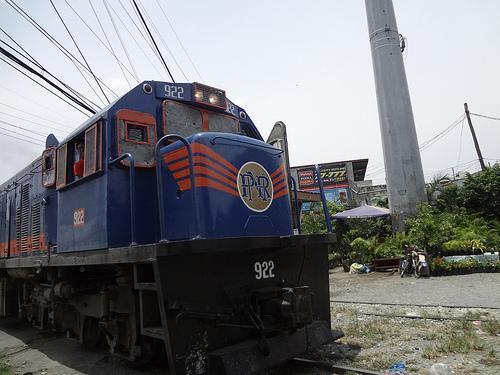How many trains are pictured?
Give a very brief answer. 1. 